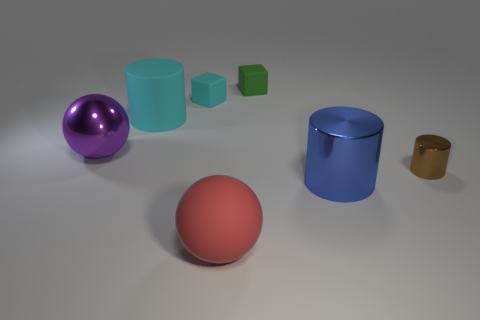Add 2 small red matte things. How many objects exist? 9 Subtract all cubes. How many objects are left? 5 Add 7 large purple things. How many large purple things exist? 8 Subtract 0 gray cubes. How many objects are left? 7 Subtract all metal cylinders. Subtract all matte objects. How many objects are left? 1 Add 2 large red balls. How many large red balls are left? 3 